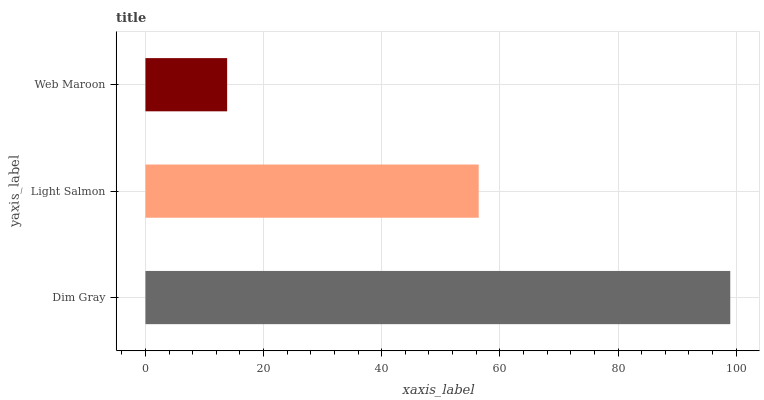Is Web Maroon the minimum?
Answer yes or no. Yes. Is Dim Gray the maximum?
Answer yes or no. Yes. Is Light Salmon the minimum?
Answer yes or no. No. Is Light Salmon the maximum?
Answer yes or no. No. Is Dim Gray greater than Light Salmon?
Answer yes or no. Yes. Is Light Salmon less than Dim Gray?
Answer yes or no. Yes. Is Light Salmon greater than Dim Gray?
Answer yes or no. No. Is Dim Gray less than Light Salmon?
Answer yes or no. No. Is Light Salmon the high median?
Answer yes or no. Yes. Is Light Salmon the low median?
Answer yes or no. Yes. Is Web Maroon the high median?
Answer yes or no. No. Is Web Maroon the low median?
Answer yes or no. No. 